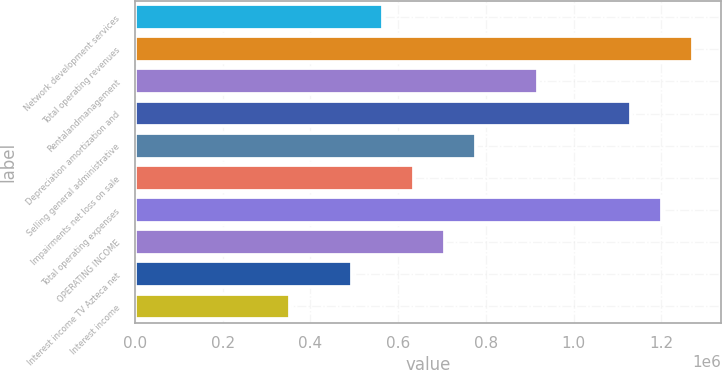<chart> <loc_0><loc_0><loc_500><loc_500><bar_chart><fcel>Network development services<fcel>Total operating revenues<fcel>Rentalandmanagement<fcel>Depreciation amortization and<fcel>Selling general administrative<fcel>Impairments net loss on sale<fcel>Total operating expenses<fcel>OPERATING INCOME<fcel>Interest income TV Azteca net<fcel>Interest income<nl><fcel>565328<fcel>1.27199e+06<fcel>918658<fcel>1.13066e+06<fcel>777326<fcel>635994<fcel>1.20132e+06<fcel>706660<fcel>494662<fcel>353331<nl></chart> 